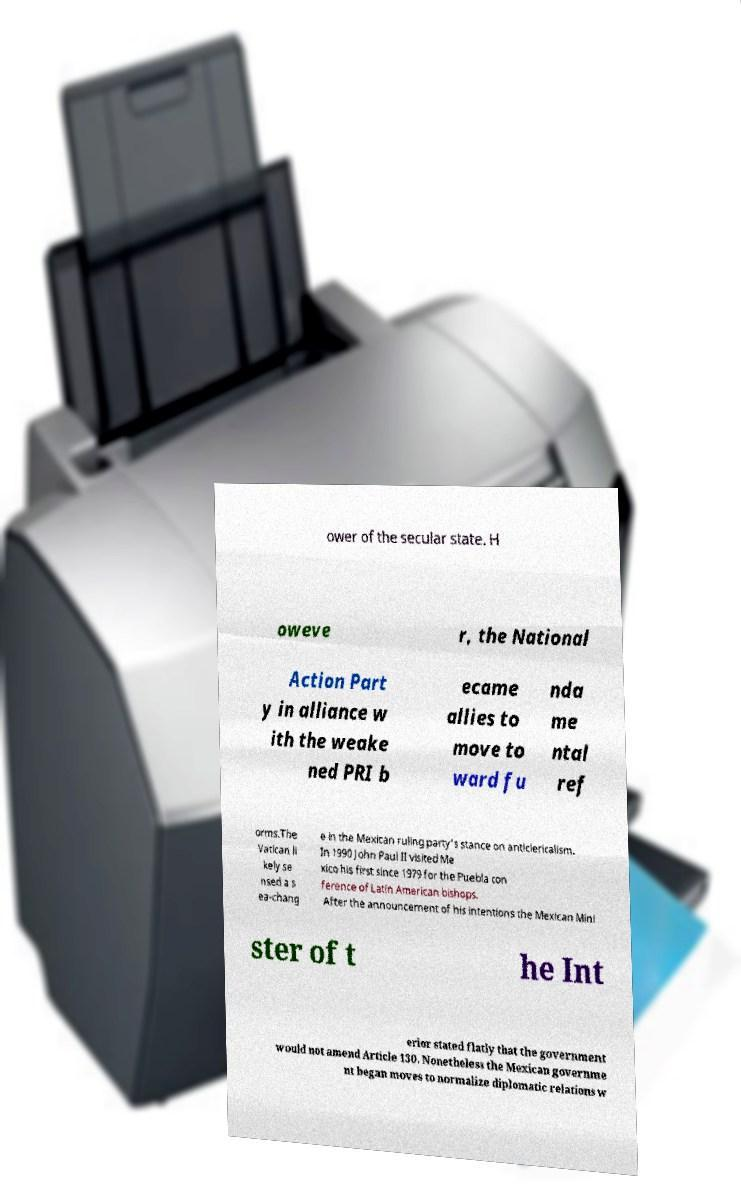Please read and relay the text visible in this image. What does it say? ower of the secular state. H oweve r, the National Action Part y in alliance w ith the weake ned PRI b ecame allies to move to ward fu nda me ntal ref orms.The Vatican li kely se nsed a s ea-chang e in the Mexican ruling party's stance on anticlericalism. In 1990 John Paul II visited Me xico his first since 1979 for the Puebla con ference of Latin American bishops. After the announcement of his intentions the Mexican Mini ster of t he Int erior stated flatly that the government would not amend Article 130. Nonetheless the Mexican governme nt began moves to normalize diplomatic relations w 